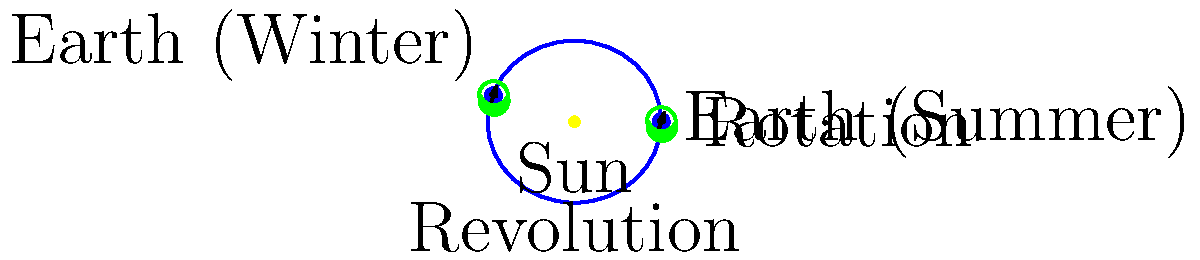As an Olympic judo athlete, you understand the importance of balance and rotation. In astronomy, Earth's rotation and revolution play crucial roles. Based on the diagram, explain how Earth's axial tilt affects the seasons and day length during its revolution around the Sun. How might this knowledge relate to planning your training schedule for the Olympics? 1. Earth's axis tilt:
   - The diagram shows Earth's axis tilted at approximately 23.5° relative to its orbital plane.
   - This tilt remains constant throughout Earth's revolution around the Sun.

2. Revolution and seasons:
   - Earth's revolution around the Sun takes approximately 365.25 days.
   - The diagram shows two positions: summer (right) and winter (left) for the Northern Hemisphere.

3. Effect on seasons:
   - Summer position: The Northern Hemisphere is tilted towards the Sun, receiving more direct sunlight.
   - Winter position: The Northern Hemisphere is tilted away from the Sun, receiving less direct sunlight.
   - This difference in solar radiation causes the seasons.

4. Day length variation:
   - Summer: Longer days in the Northern Hemisphere due to more hours of sunlight.
   - Winter: Shorter days in the Northern Hemisphere due to fewer hours of sunlight.

5. Impact on training schedule:
   - Longer summer days provide more natural light for outdoor training.
   - Shorter winter days may require adjusting training times or using indoor facilities.
   - Temperature variations due to seasons may affect training intensity and recovery needs.

6. Relevance to Olympic preparation:
   - Understanding these cycles helps in planning training phases aligned with seasonal changes.
   - Adapting to different day lengths and climates is crucial for international competitions.
   - Optimizing training based on natural light availability can improve performance and recovery.
Answer: Earth's axial tilt causes seasons and varying day lengths during its revolution, affecting training schedules through changes in daylight hours and climate conditions. 